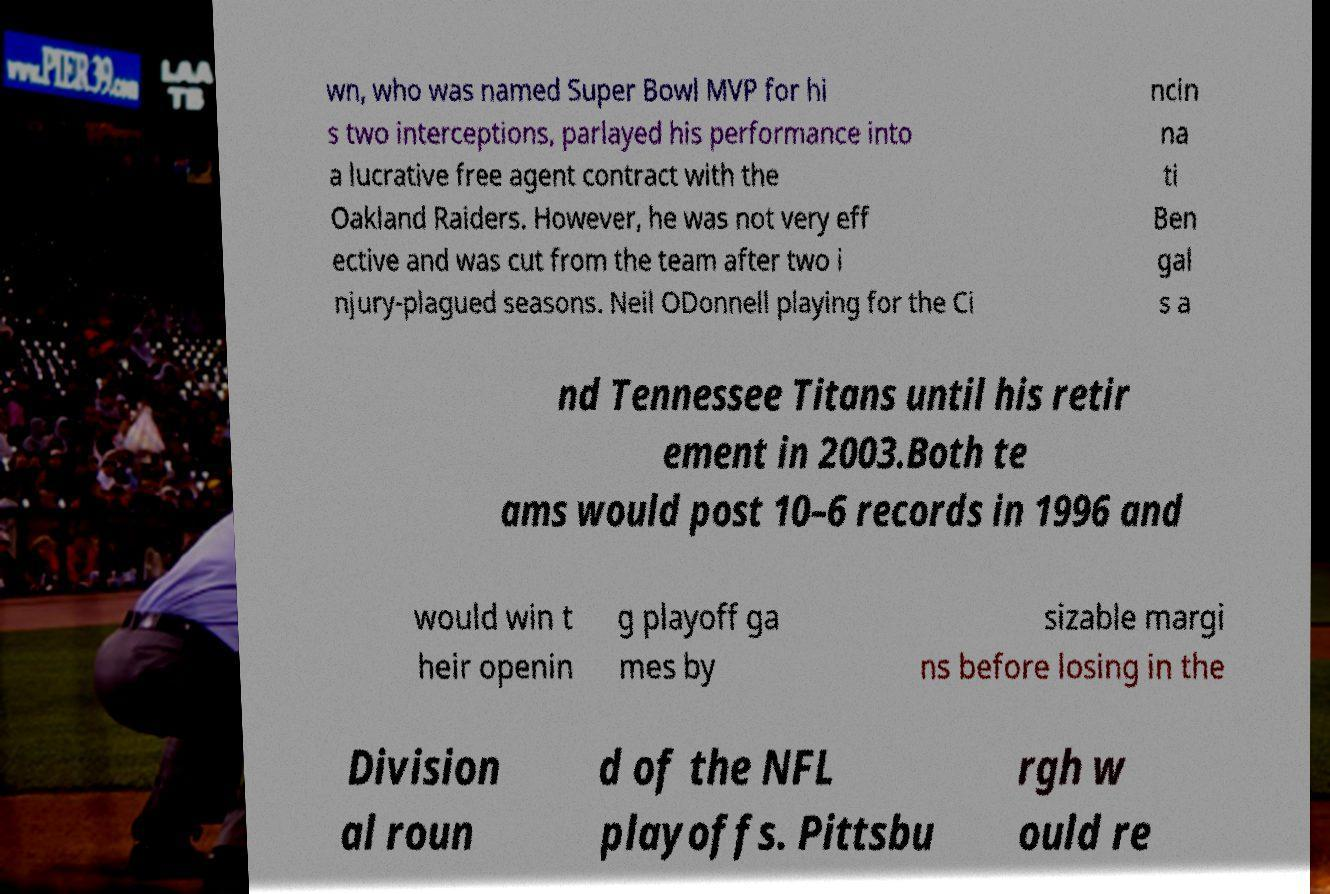Could you extract and type out the text from this image? wn, who was named Super Bowl MVP for hi s two interceptions, parlayed his performance into a lucrative free agent contract with the Oakland Raiders. However, he was not very eff ective and was cut from the team after two i njury-plagued seasons. Neil ODonnell playing for the Ci ncin na ti Ben gal s a nd Tennessee Titans until his retir ement in 2003.Both te ams would post 10–6 records in 1996 and would win t heir openin g playoff ga mes by sizable margi ns before losing in the Division al roun d of the NFL playoffs. Pittsbu rgh w ould re 